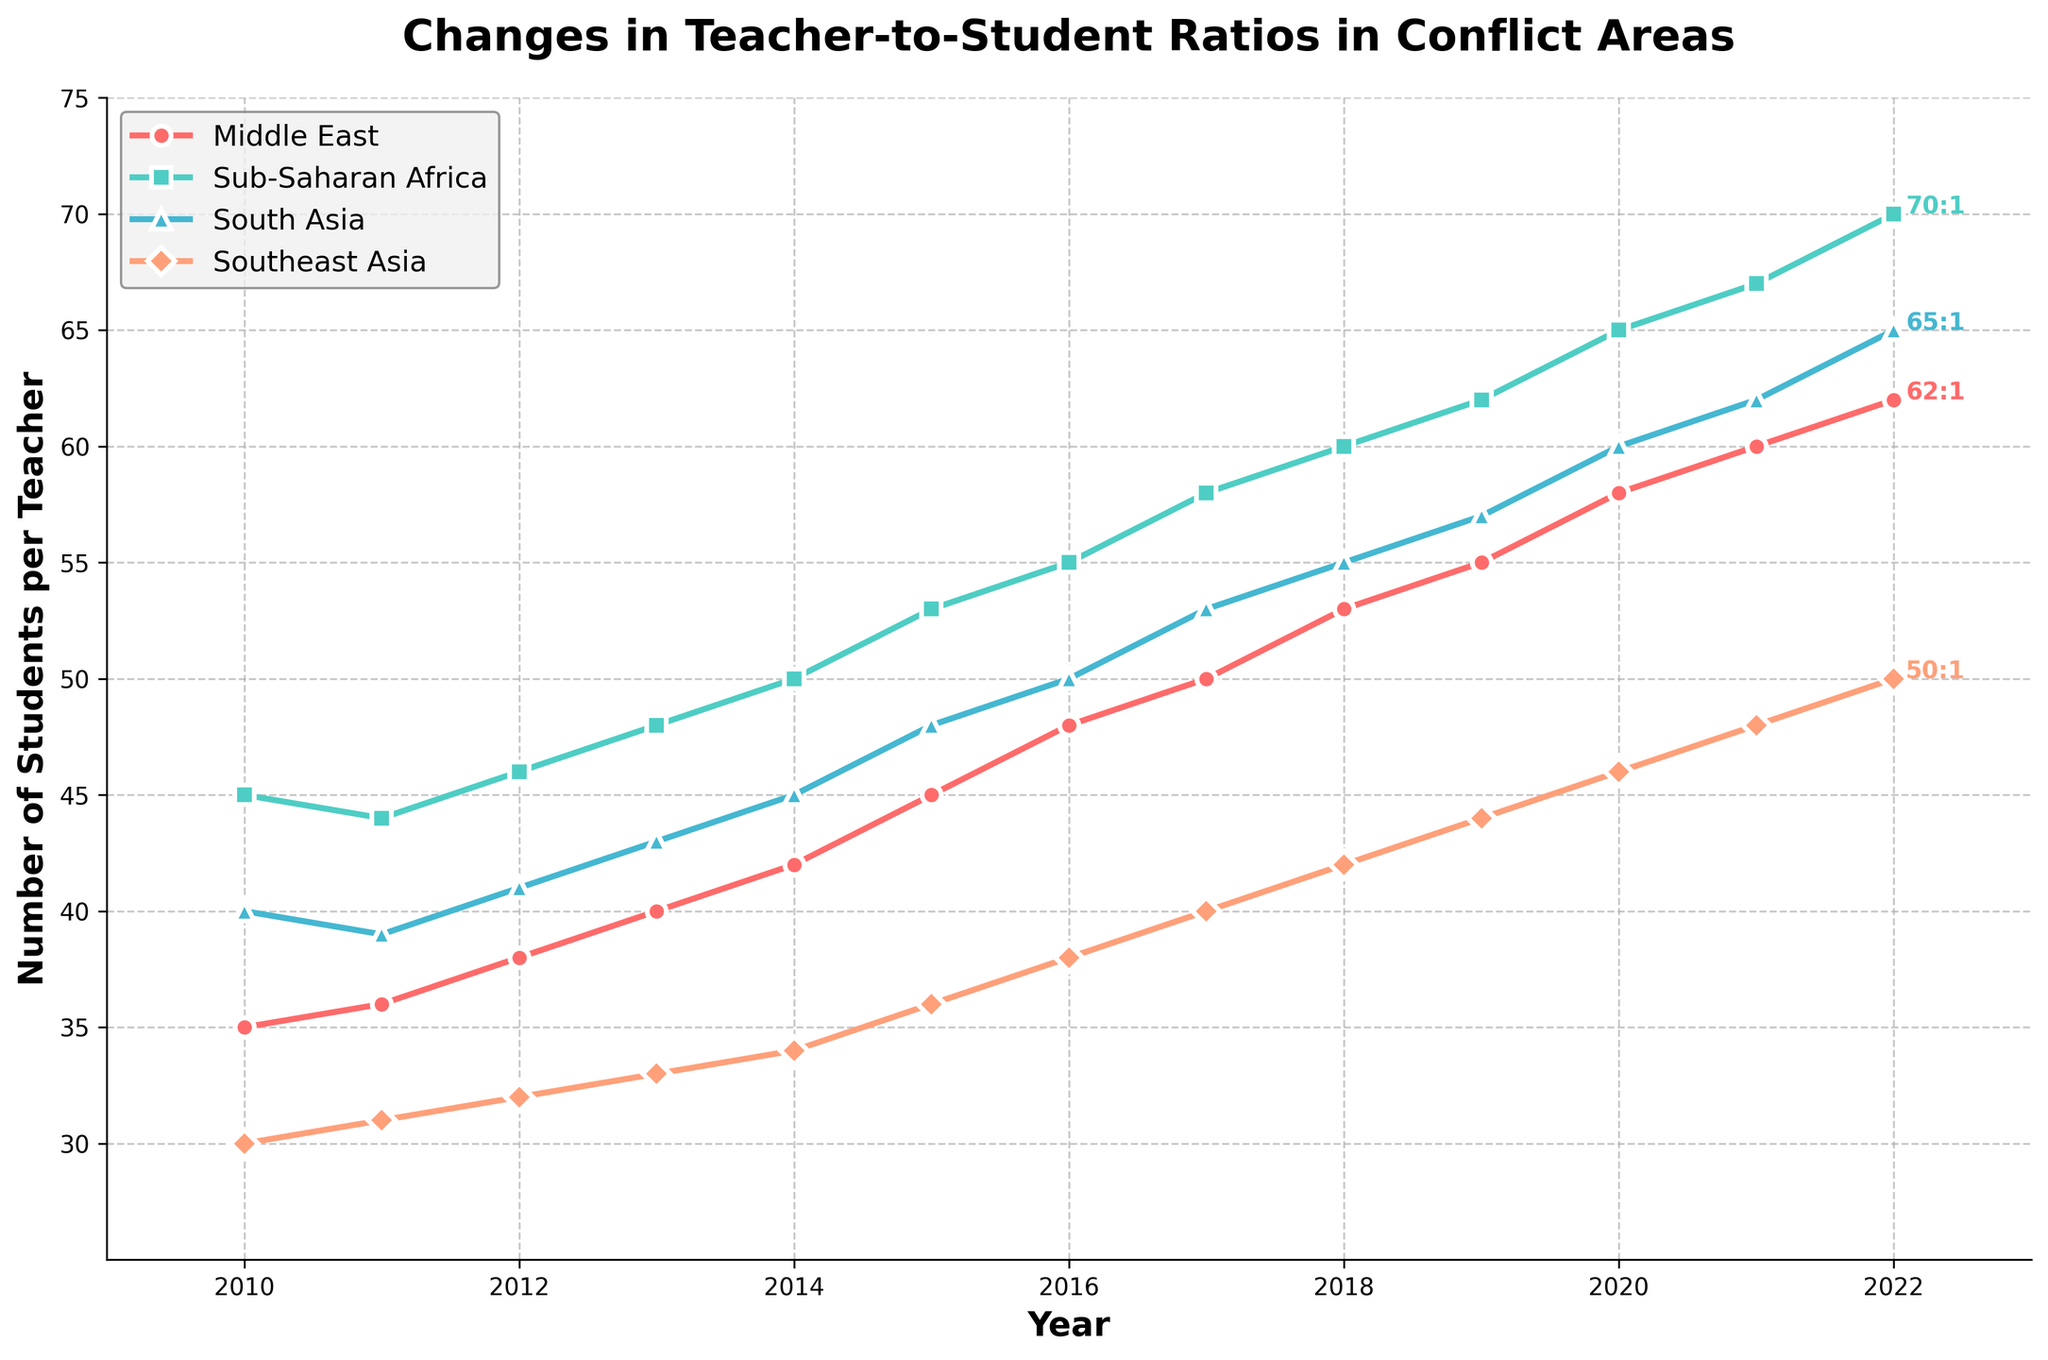What was the teacher-to-student ratio in the Sub-Saharan Africa region in 2010 and 2022? In 2010, the ratio for Sub-Saharan Africa was at the starting point of the chart, marked as 1:45. In 2022, it has progressed to the end of the chart, marked as 1:70.
Answer: 1:45 in 2010, 1:70 in 2022 Which region had the lowest teacher-to-student ratio in 2022? By examining the end of each of the lines, Southeast Asia had the lowest teacher-to-student ratio in 2022, marked as 1:50.
Answer: Southeast Asia How much did the teacher-to-student ratio in the Middle East change from 2010 to 2022? The ratio in the Middle East was 1:35 in 2010 and changed to 1:62 in 2022. The change is calculated as 62 - 35 = 27.
Answer: 27 Which region showed the greatest increase in teacher-to-student ratio over the entire period? By observing the lines, Sub-Saharan Africa shows the steepest increase, going from 1:45 in 2010 to 1:70 in 2022, an increase of 25.
Answer: Sub-Saharan Africa By how many students per teacher did the teacher-to-student ratio increase in South Asia from 2010 to 2020? In 2010, the ratio in South Asia was 1:40. By 2020, this ratio had increased to 1:60. The increase is calculated as 60 - 40 = 20.
Answer: 20 What is the difference in teacher-to-student ratios between Sub-Saharan Africa and Southeast Asia in 2022? In 2022, Sub-Saharan Africa had a ratio of 1:70, and Southeast Asia had a ratio of 1:50. The difference is 70 - 50 = 20.
Answer: 20 Identify the year when the teacher-to-student ratio in the Middle East began to consistently exceed 1:50. Observing the plot, the teacher-to-student ratio in the Middle East exceeds 1:50 starting in the year 2017 and remains above this threshold thereafter.
Answer: 2017 Which region experienced the least change in teacher-to-student ratios from 2010 to 2022? Southeast Asia experienced the least change, with its ratio moving from 1:30 in 2010 to 1:50 in 2022, a difference of 20. The other regions show a greater change in their ratios.
Answer: Southeast Asia How does the teacher-to-student ratio trend in South Asia compare to that in the Middle East between 2015 and 2020? Both regions exhibit an upward trend in teacher-to-student ratios during this period. However, the increase is steeper in South Asia, where it rises from 1:48 to 1:60, compared to an increase in the Middle East from 1:45 to 1:58.
Answer: Both increasing, but steeper in South Asia 